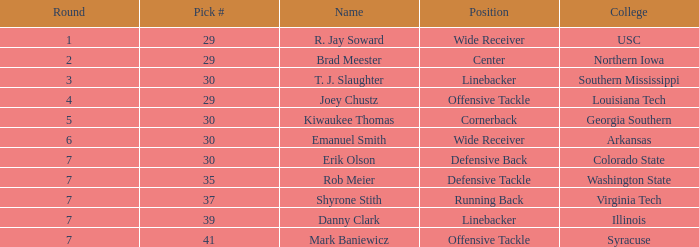What was r. jay soward's position when he was chosen in the third round of the draft? Wide Receiver. 